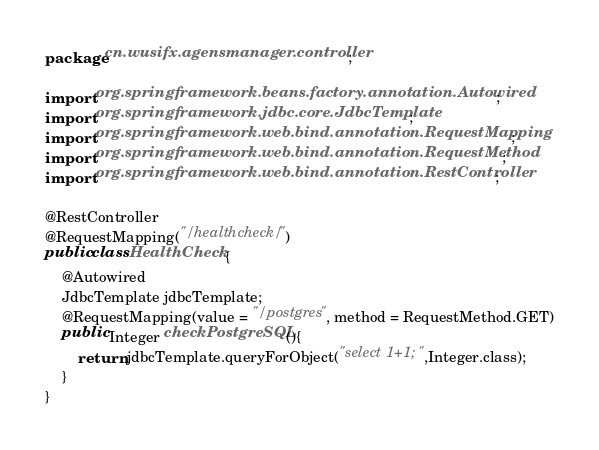Convert code to text. <code><loc_0><loc_0><loc_500><loc_500><_Java_>package cn.wusifx.agensmanager.controller;

import org.springframework.beans.factory.annotation.Autowired;
import org.springframework.jdbc.core.JdbcTemplate;
import org.springframework.web.bind.annotation.RequestMapping;
import org.springframework.web.bind.annotation.RequestMethod;
import org.springframework.web.bind.annotation.RestController;

@RestController
@RequestMapping("/healthcheck/")
public class HealthCheck {
    @Autowired
    JdbcTemplate jdbcTemplate;
    @RequestMapping(value = "/postgres", method = RequestMethod.GET)
    public Integer checkPostgreSQL(){
        return jdbcTemplate.queryForObject("select 1+1;",Integer.class);
    }
}
</code> 